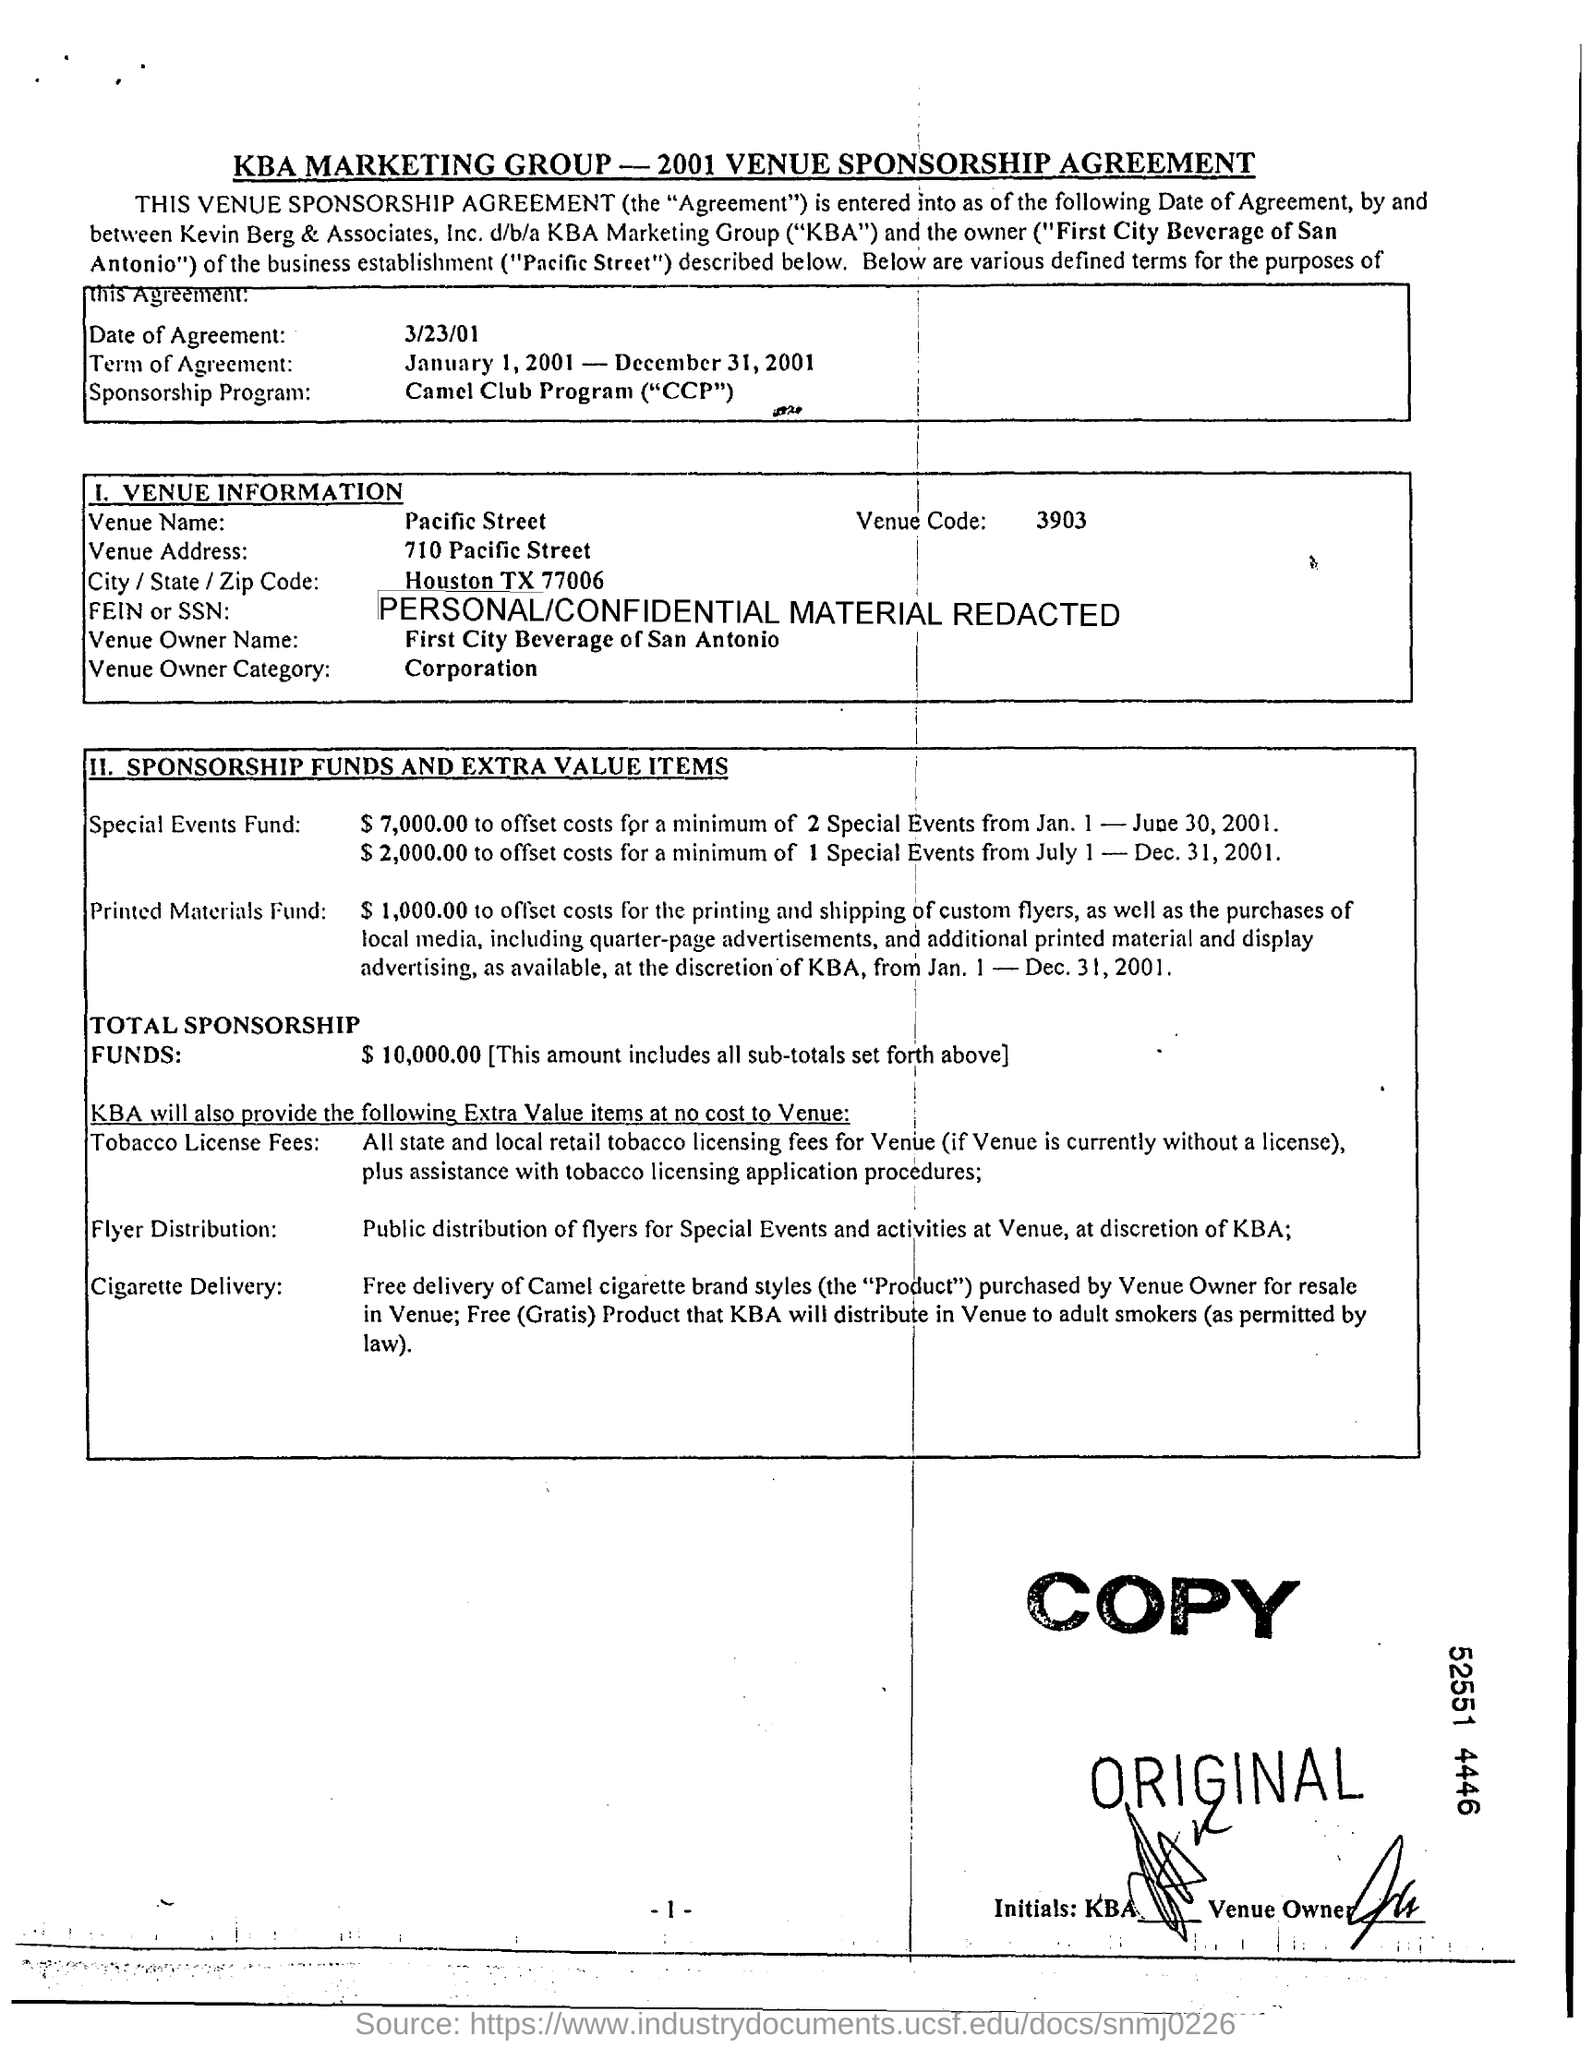What is the Venue Code?
Offer a terse response. 3903. What is the Venue Owner Category?
Offer a terse response. Corporation. What is the Venue Name?
Make the answer very short. Pacific Street. What is the Date of Agreement?
Provide a short and direct response. 3/23/01. 